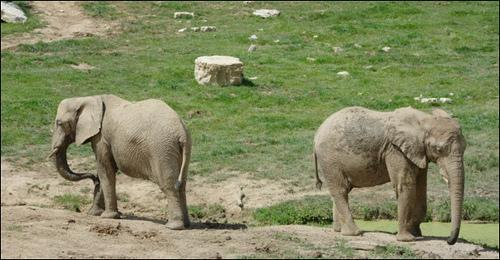What elements make the image interesting? The presence of two opposite-facing elephants, variation in the terrain, and the visual details such as wet trunks and elephant ears make the image interesting. Write a short narrative of what is happening in the image. Two elephants are standing in a green field filled with rocks and patches of dirt. The one on the right seems to have just drank from a green murky stream, while the one on the left is lifting its trunk. Mention the notable features of the landscape in the image. The landscape features a green grass field with dirt patches, rocks, a stream, and a hill with a dirt path. Describe the environment where the elephants are. The elephants are standing in a green grass field with patches of dirt, rocks, and a green murky stream creating a lush and natural scene. Write a summary of what the viewer can see in the image. The viewer sees two elephants with diverse features in a green field surrounded by various elements like rocks, dirt patches, a stream, and a diverse landscape. Explain the overall setting of the image. The image is set in a green grass field with elephants, rocks, a stream, dirt patches, and weed growing by the stream. What are the key characteristics of the elephants in the image? Both elephants have short tusks, really big ears, and one has a wet trunk end while the other appears to have been rolling in mud. Describe the action of the two main characters in the image. The two elephants are the focus of the picture, one is in the process of lifting its trunk while the other appears to have just drank water. Provide a brief description of the main elements in the image. There are two elephants in the green field, facing opposite directions, with short tusks, big ears, and lifting their trunks. List five objects or characteristics found in the image. Elephants, green grass, rocks, trunks, dirt path. 